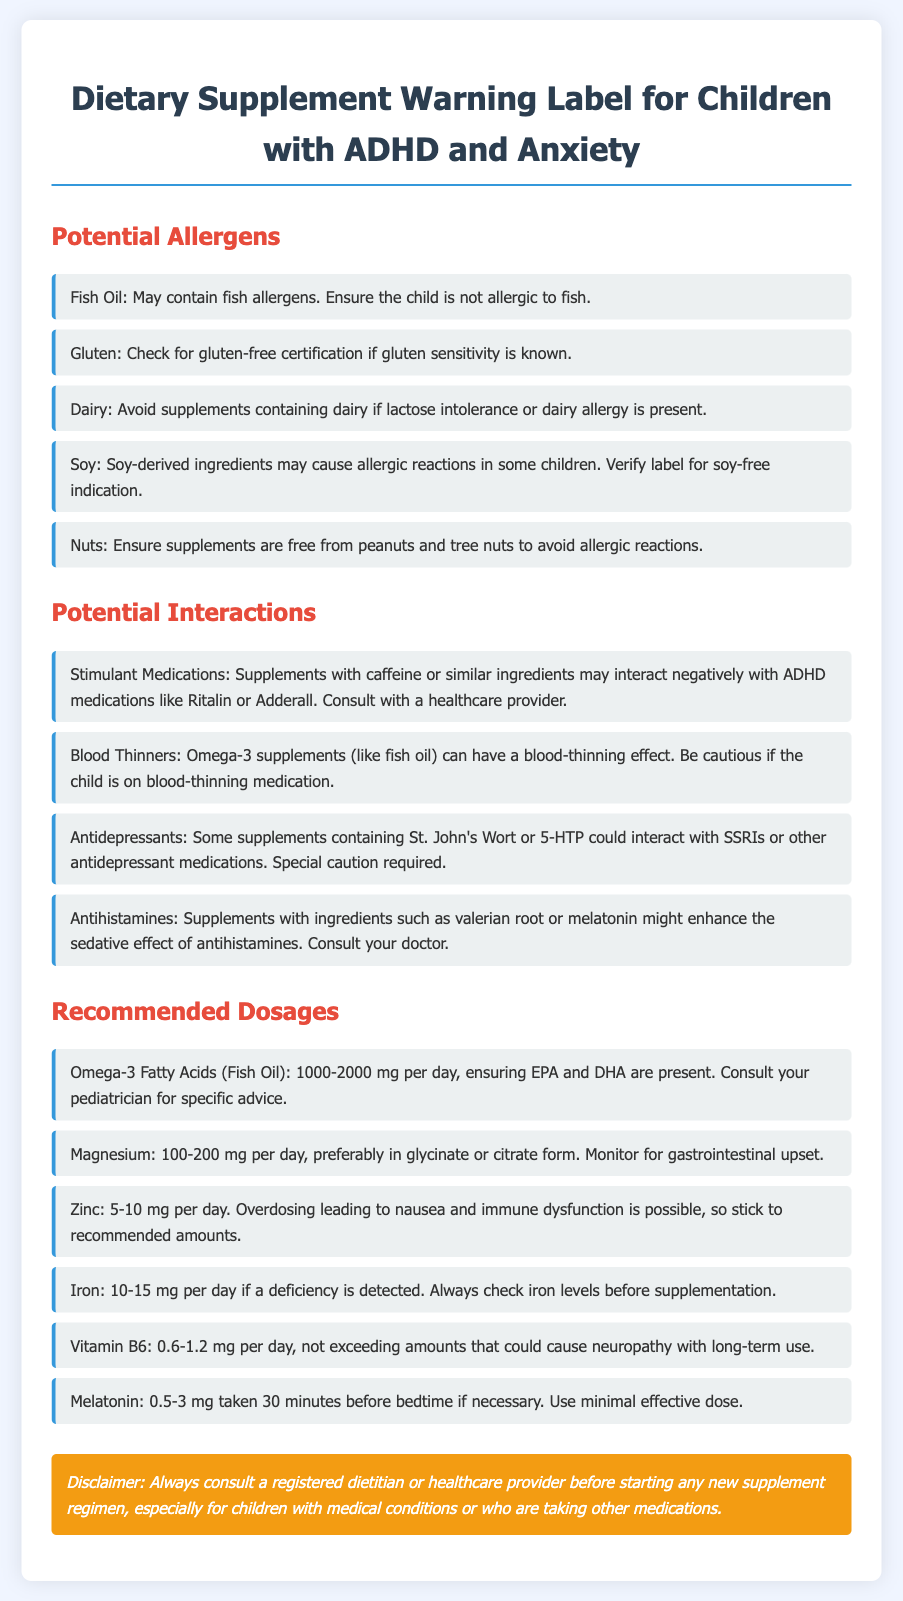what is the daily recommended dosage of Omega-3 Fatty Acids for children? The document mentions the recommended dosage of Omega-3 Fatty Acids (Fish Oil) as 1000-2000 mg per day.
Answer: 1000-2000 mg which allergen should be avoided if the child has a lactose intolerance? The document states that dairy should be avoided if lactose intolerance or a dairy allergy is present.
Answer: Dairy what is the potential interaction with stimulant medications? The document indicates that supplements with caffeine or similar ingredients may negatively interact with ADHD medications like Ritalin or Adderall.
Answer: Caffeine what is the suggested dosage of zinc per day? The document recommends a daily dosage of 5-10 mg of zinc.
Answer: 5-10 mg which ingredient may enhance the sedative effect of antihistamines? The document mentions that supplements with valerian root or melatonin might enhance the sedative effect of antihistamines.
Answer: Valerian root or melatonin is it necessary to consult a healthcare provider before starting new supplements? The disclaimer in the document stresses the importance of consulting a registered dietitian or healthcare provider before starting any new supplement regimen.
Answer: Yes what should be monitored when taking magnesium supplements? The document mentions monitoring for gastrointestinal upset when taking magnesium supplements.
Answer: Gastrointestinal upset which allergen is specifically related to fish? The document states that fish oil may contain fish allergens.
Answer: Fish what is the recommended iron dosage if a deficiency is detected? According to the document, the recommended iron dosage is 10-15 mg per day if a deficiency is detected.
Answer: 10-15 mg 